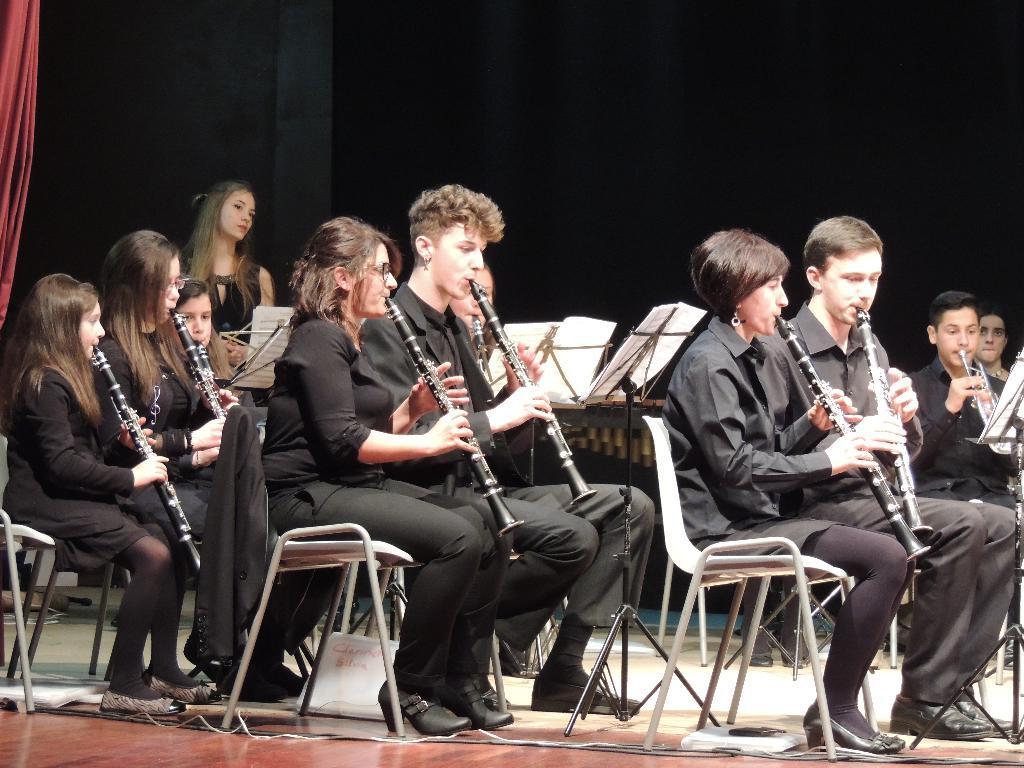How would you summarize this image in a sentence or two? In this image I can see number of people sitting on chairs, I can also see they all are holding musical instruments. In the background I can see a girl is standing. 